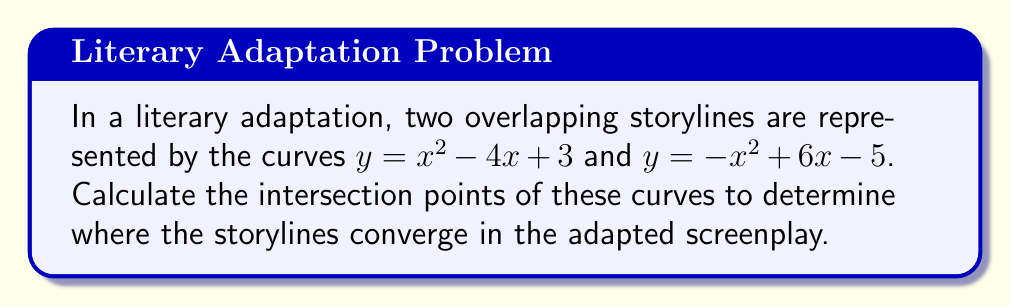Give your solution to this math problem. To find the intersection points of the two curves, we need to solve the equation:

$$x^2 - 4x + 3 = -x^2 + 6x - 5$$

Step 1: Rearrange the equation to standard form.
$$x^2 - 4x + 3 + x^2 - 6x + 5 = 0$$
$$2x^2 - 10x + 8 = 0$$

Step 2: Divide all terms by 2 to simplify.
$$x^2 - 5x + 4 = 0$$

Step 3: Use the quadratic formula $x = \frac{-b \pm \sqrt{b^2 - 4ac}}{2a}$, where $a=1$, $b=-5$, and $c=4$.

$$x = \frac{5 \pm \sqrt{25 - 16}}{2} = \frac{5 \pm 3}{2}$$

Step 4: Solve for the two x-values.
$$x_1 = \frac{5 + 3}{2} = 4$$
$$x_2 = \frac{5 - 3}{2} = 1$$

Step 5: Calculate the corresponding y-values by substituting x into either original equation. Let's use $y = x^2 - 4x + 3$.

For $x_1 = 4$:
$$y_1 = 4^2 - 4(4) + 3 = 16 - 16 + 3 = 3$$

For $x_2 = 1$:
$$y_2 = 1^2 - 4(1) + 3 = 1 - 4 + 3 = 0$$

Therefore, the intersection points are (4, 3) and (1, 0).
Answer: (4, 3) and (1, 0) 